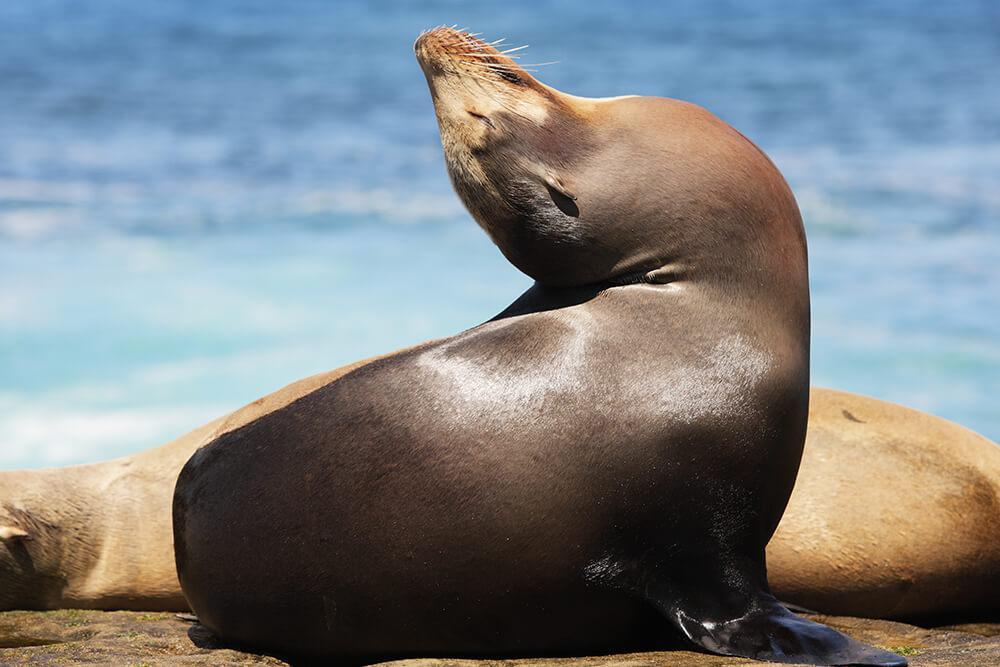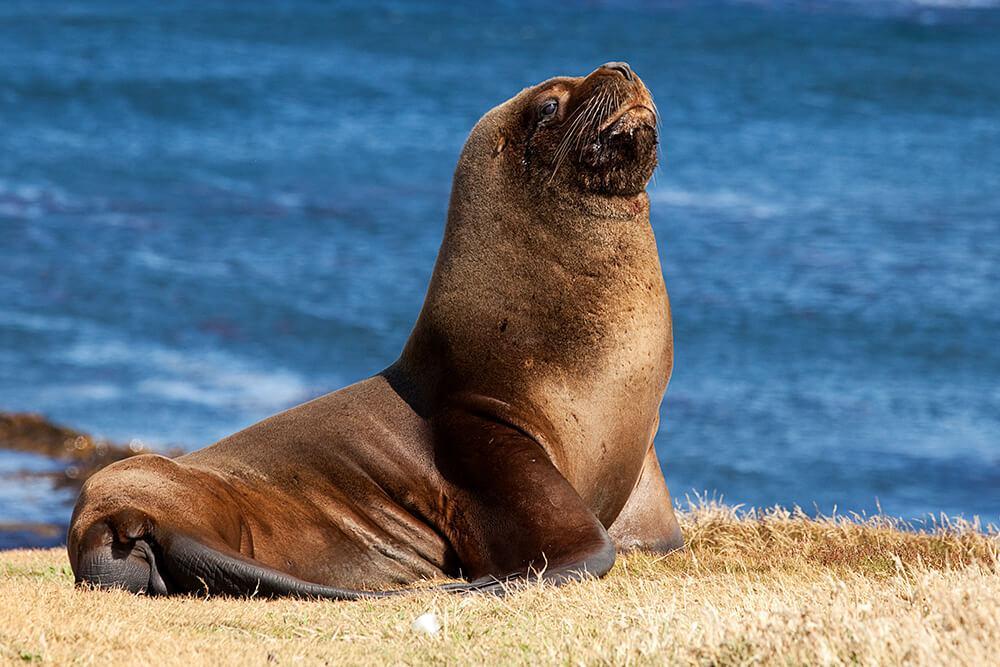The first image is the image on the left, the second image is the image on the right. For the images displayed, is the sentence "Blue water is visible in both images of seals." factually correct? Answer yes or no. Yes. The first image is the image on the left, the second image is the image on the right. Evaluate the accuracy of this statement regarding the images: "One image shows a seal on sand without water clearly visible.". Is it true? Answer yes or no. No. 